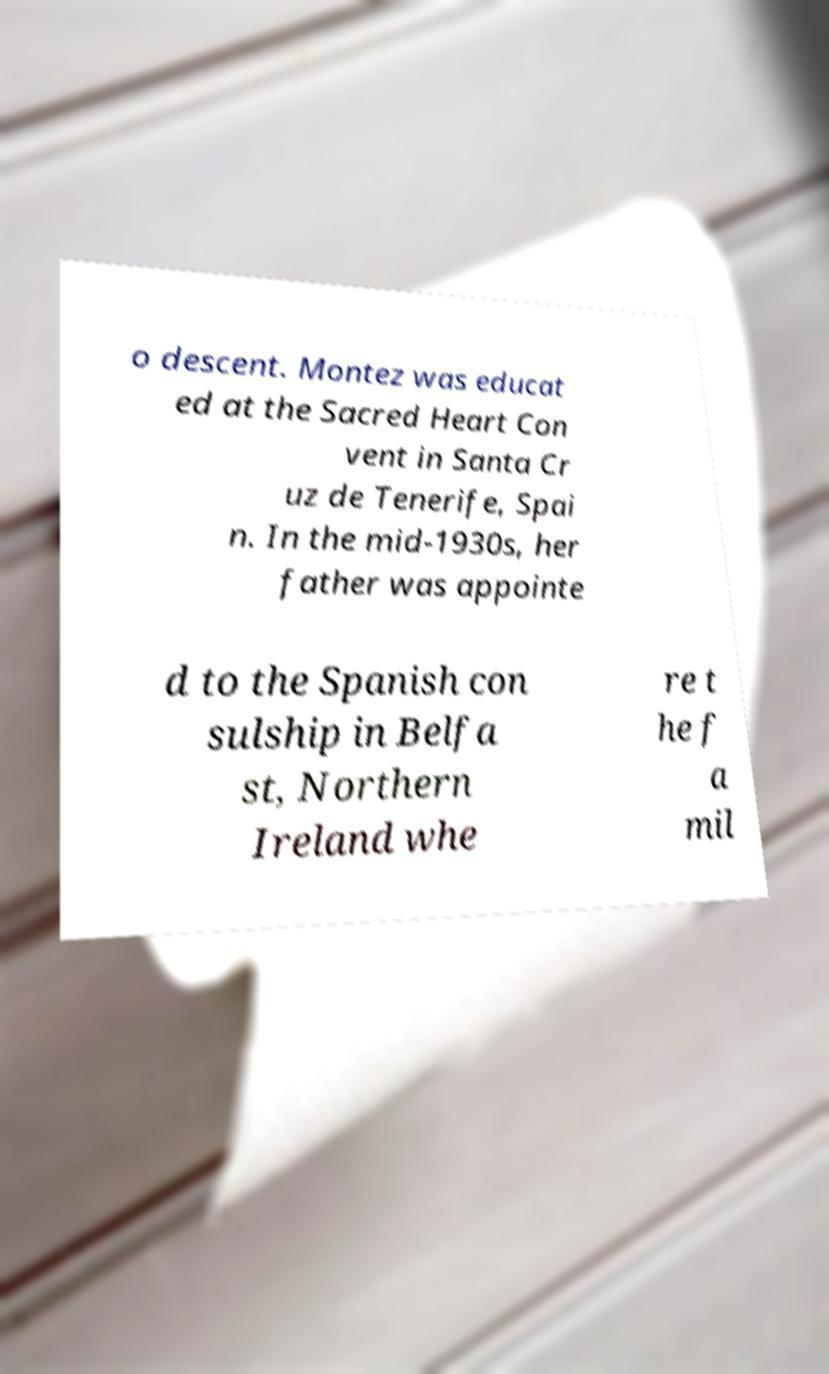There's text embedded in this image that I need extracted. Can you transcribe it verbatim? o descent. Montez was educat ed at the Sacred Heart Con vent in Santa Cr uz de Tenerife, Spai n. In the mid-1930s, her father was appointe d to the Spanish con sulship in Belfa st, Northern Ireland whe re t he f a mil 